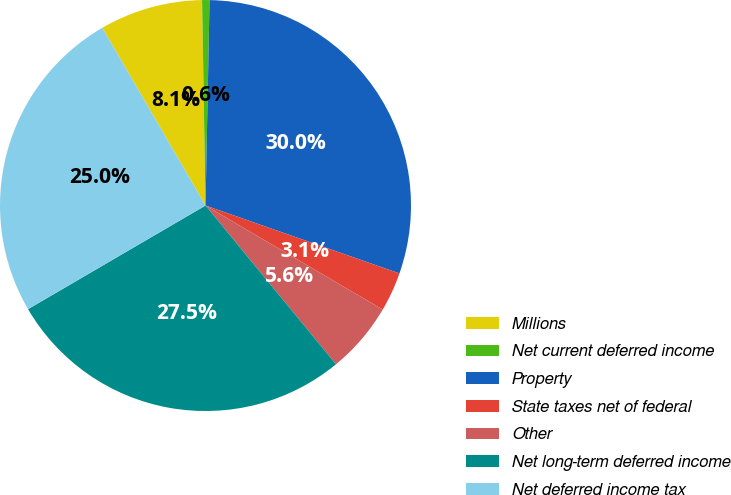Convert chart. <chart><loc_0><loc_0><loc_500><loc_500><pie_chart><fcel>Millions<fcel>Net current deferred income<fcel>Property<fcel>State taxes net of federal<fcel>Other<fcel>Net long-term deferred income<fcel>Net deferred income tax<nl><fcel>8.11%<fcel>0.58%<fcel>30.05%<fcel>3.09%<fcel>5.6%<fcel>27.54%<fcel>25.04%<nl></chart> 